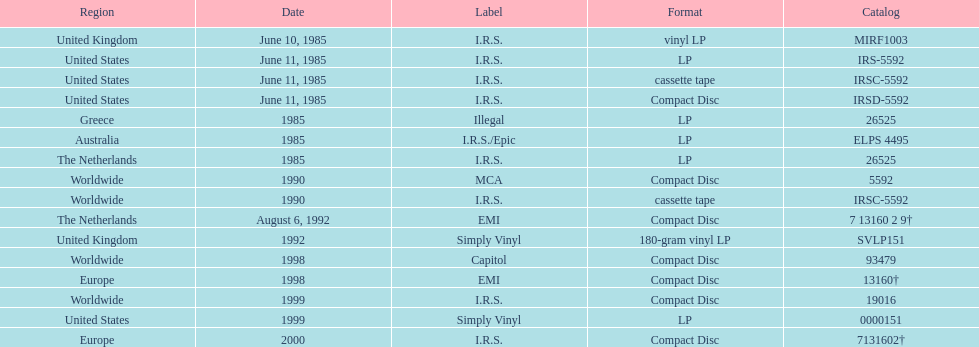What is the greatest consecutive amount of releases in lp format? 3. 